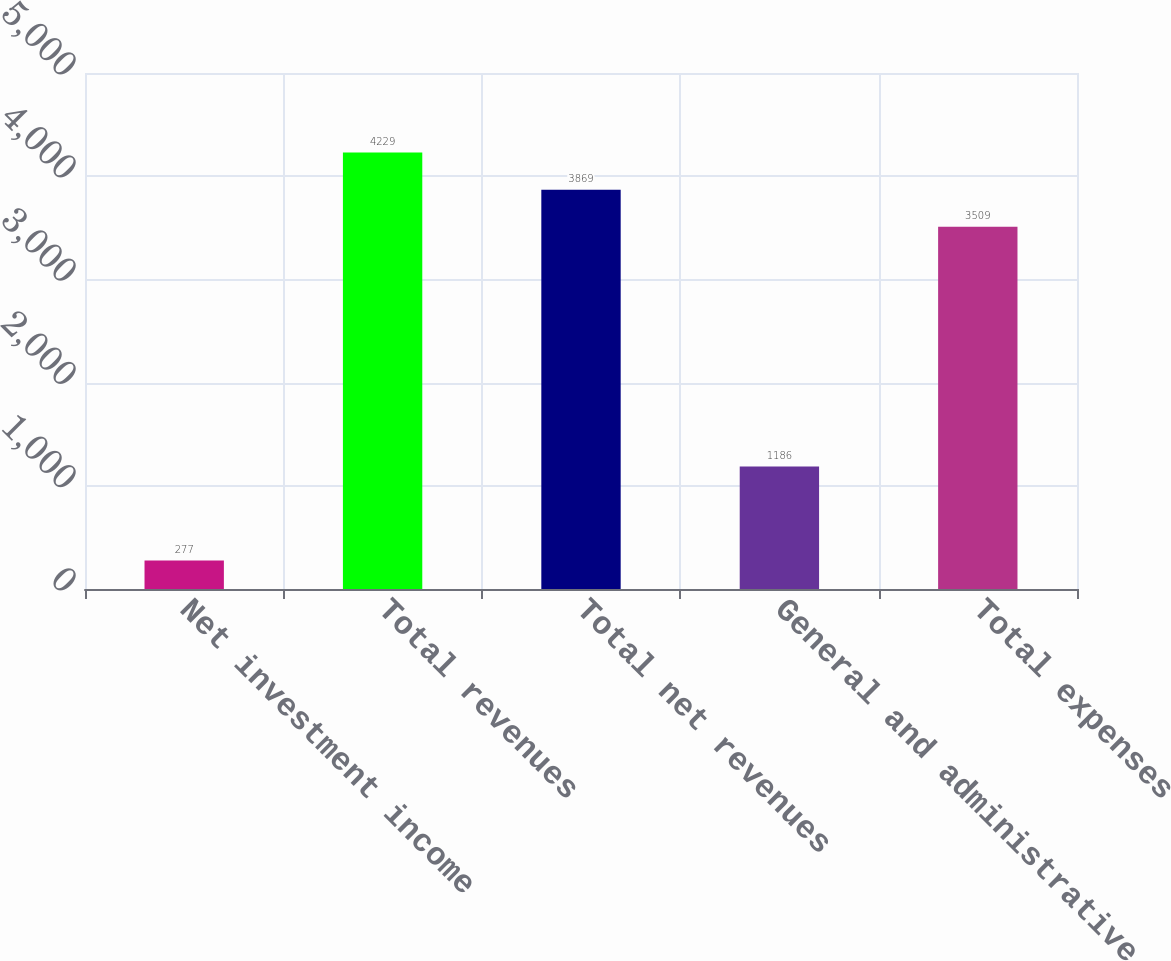Convert chart. <chart><loc_0><loc_0><loc_500><loc_500><bar_chart><fcel>Net investment income<fcel>Total revenues<fcel>Total net revenues<fcel>General and administrative<fcel>Total expenses<nl><fcel>277<fcel>4229<fcel>3869<fcel>1186<fcel>3509<nl></chart> 